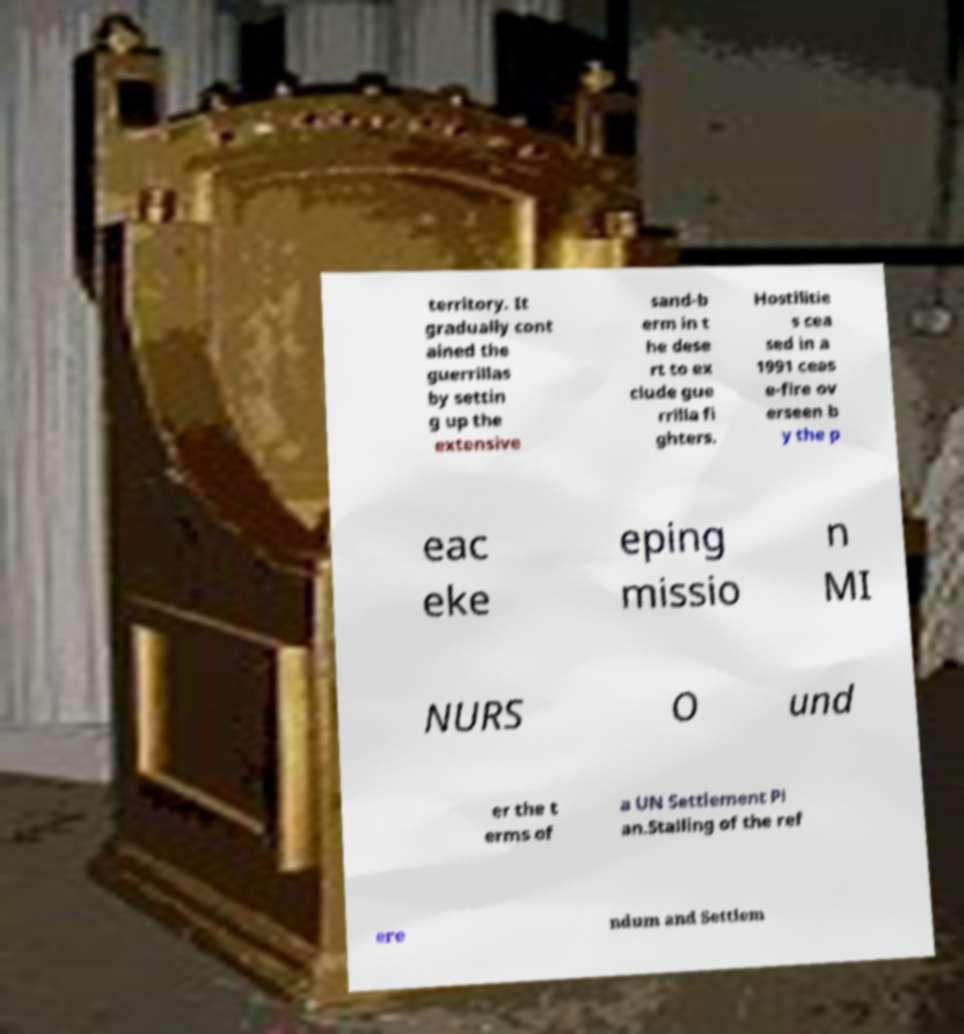I need the written content from this picture converted into text. Can you do that? territory. It gradually cont ained the guerrillas by settin g up the extensive sand-b erm in t he dese rt to ex clude gue rrilla fi ghters. Hostilitie s cea sed in a 1991 ceas e-fire ov erseen b y the p eac eke eping missio n MI NURS O und er the t erms of a UN Settlement Pl an.Stalling of the ref ere ndum and Settlem 